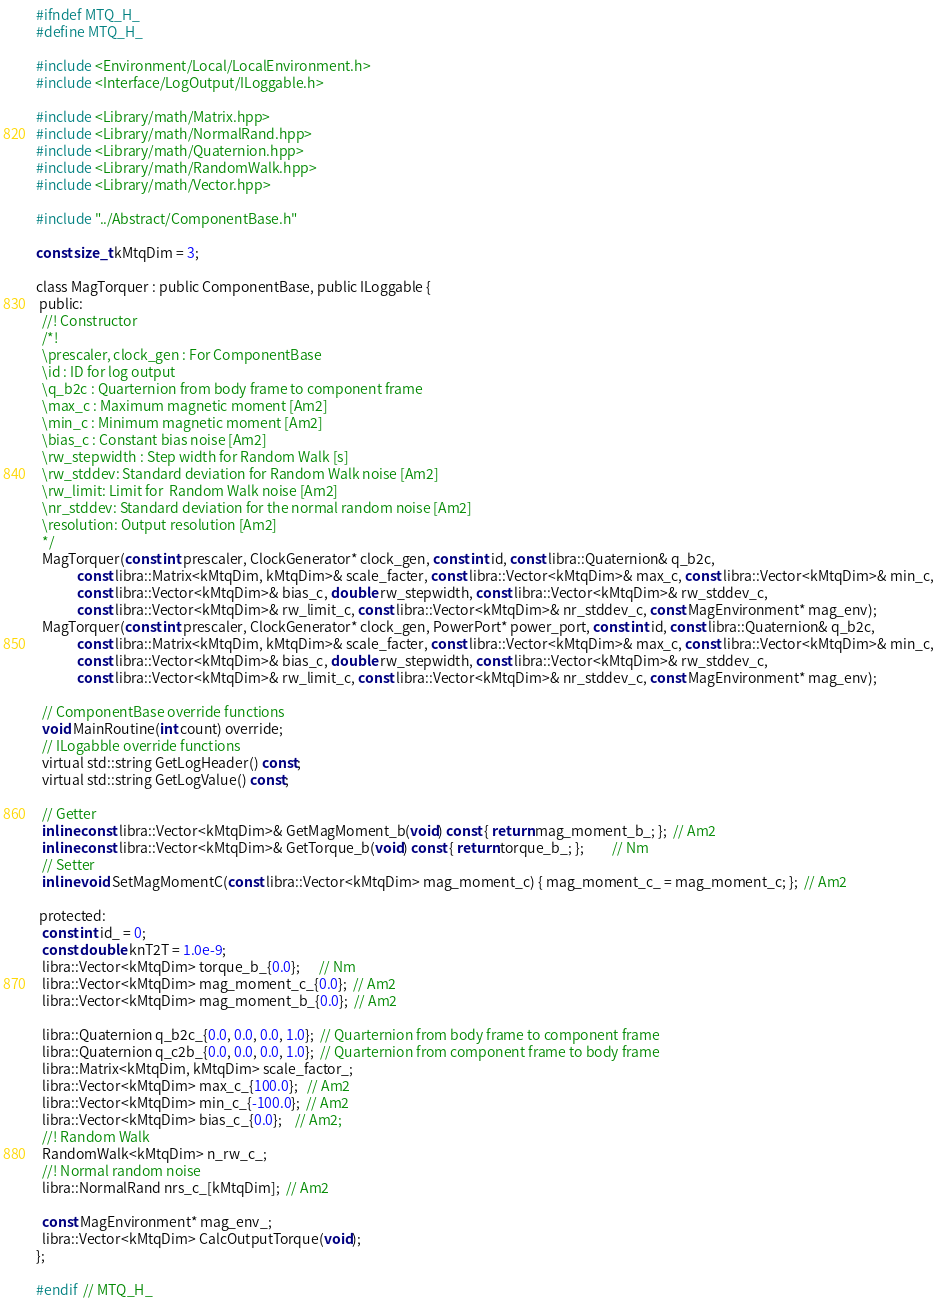Convert code to text. <code><loc_0><loc_0><loc_500><loc_500><_C_>#ifndef MTQ_H_
#define MTQ_H_

#include <Environment/Local/LocalEnvironment.h>
#include <Interface/LogOutput/ILoggable.h>

#include <Library/math/Matrix.hpp>
#include <Library/math/NormalRand.hpp>
#include <Library/math/Quaternion.hpp>
#include <Library/math/RandomWalk.hpp>
#include <Library/math/Vector.hpp>

#include "../Abstract/ComponentBase.h"

const size_t kMtqDim = 3;

class MagTorquer : public ComponentBase, public ILoggable {
 public:
  //! Constructor
  /*!
  \prescaler, clock_gen : For ComponentBase
  \id : ID for log output
  \q_b2c : Quarternion from body frame to component frame
  \max_c : Maximum magnetic moment [Am2]
  \min_c : Minimum magnetic moment [Am2]
  \bias_c : Constant bias noise [Am2]
  \rw_stepwidth : Step width for Random Walk [s]
  \rw_stddev: Standard deviation for Random Walk noise [Am2]
  \rw_limit: Limit for  Random Walk noise [Am2]
  \nr_stddev: Standard deviation for the normal random noise [Am2]
  \resolution: Output resolution [Am2]
  */
  MagTorquer(const int prescaler, ClockGenerator* clock_gen, const int id, const libra::Quaternion& q_b2c,
             const libra::Matrix<kMtqDim, kMtqDim>& scale_facter, const libra::Vector<kMtqDim>& max_c, const libra::Vector<kMtqDim>& min_c,
             const libra::Vector<kMtqDim>& bias_c, double rw_stepwidth, const libra::Vector<kMtqDim>& rw_stddev_c,
             const libra::Vector<kMtqDim>& rw_limit_c, const libra::Vector<kMtqDim>& nr_stddev_c, const MagEnvironment* mag_env);
  MagTorquer(const int prescaler, ClockGenerator* clock_gen, PowerPort* power_port, const int id, const libra::Quaternion& q_b2c,
             const libra::Matrix<kMtqDim, kMtqDim>& scale_facter, const libra::Vector<kMtqDim>& max_c, const libra::Vector<kMtqDim>& min_c,
             const libra::Vector<kMtqDim>& bias_c, double rw_stepwidth, const libra::Vector<kMtqDim>& rw_stddev_c,
             const libra::Vector<kMtqDim>& rw_limit_c, const libra::Vector<kMtqDim>& nr_stddev_c, const MagEnvironment* mag_env);

  // ComponentBase override functions
  void MainRoutine(int count) override;
  // ILogabble override functions
  virtual std::string GetLogHeader() const;
  virtual std::string GetLogValue() const;

  // Getter
  inline const libra::Vector<kMtqDim>& GetMagMoment_b(void) const { return mag_moment_b_; };  // Am2
  inline const libra::Vector<kMtqDim>& GetTorque_b(void) const { return torque_b_; };         // Nm
  // Setter
  inline void SetMagMomentC(const libra::Vector<kMtqDim> mag_moment_c) { mag_moment_c_ = mag_moment_c; };  // Am2

 protected:
  const int id_ = 0;
  const double knT2T = 1.0e-9;
  libra::Vector<kMtqDim> torque_b_{0.0};      // Nm
  libra::Vector<kMtqDim> mag_moment_c_{0.0};  // Am2
  libra::Vector<kMtqDim> mag_moment_b_{0.0};  // Am2

  libra::Quaternion q_b2c_{0.0, 0.0, 0.0, 1.0};  // Quarternion from body frame to component frame
  libra::Quaternion q_c2b_{0.0, 0.0, 0.0, 1.0};  // Quarternion from component frame to body frame
  libra::Matrix<kMtqDim, kMtqDim> scale_factor_;
  libra::Vector<kMtqDim> max_c_{100.0};   // Am2
  libra::Vector<kMtqDim> min_c_{-100.0};  // Am2
  libra::Vector<kMtqDim> bias_c_{0.0};    // Am2;
  //! Random Walk
  RandomWalk<kMtqDim> n_rw_c_;
  //! Normal random noise
  libra::NormalRand nrs_c_[kMtqDim];  // Am2

  const MagEnvironment* mag_env_;
  libra::Vector<kMtqDim> CalcOutputTorque(void);
};

#endif  // MTQ_H_
</code> 